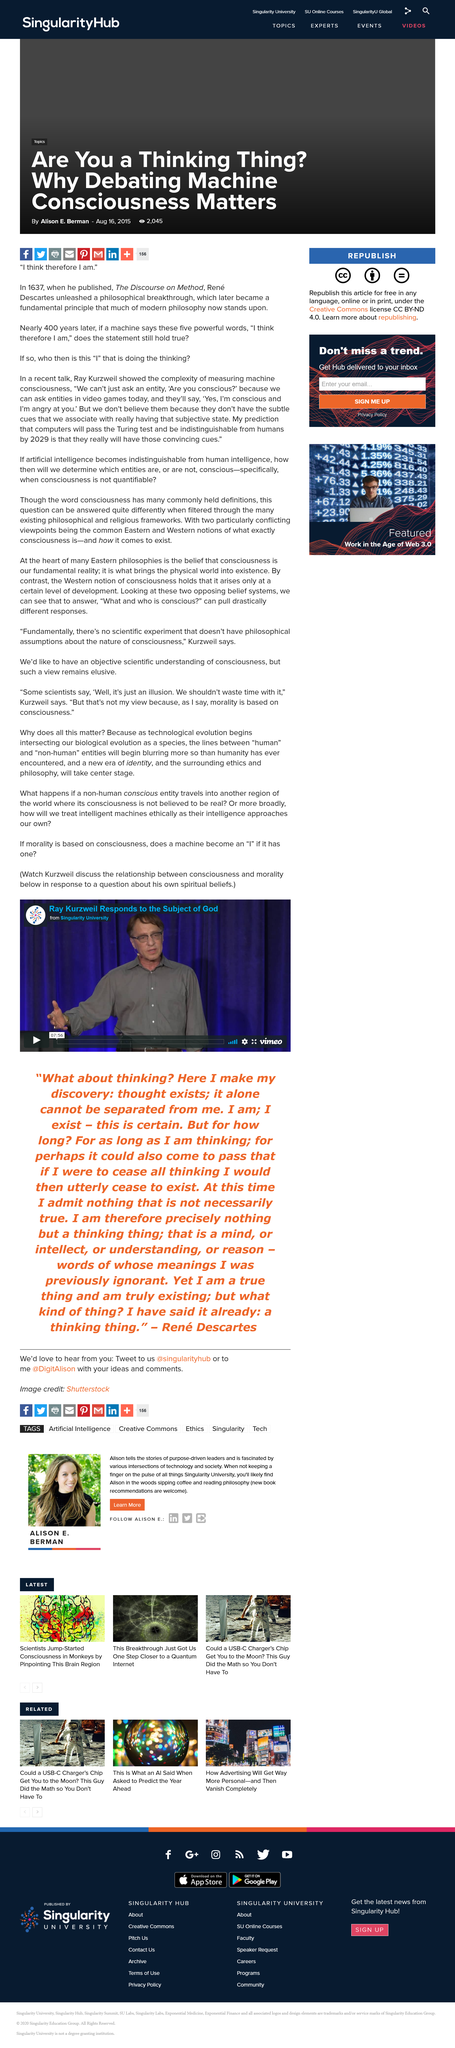Draw attention to some important aspects in this diagram. In the Singularity University Vimeo video, Ray Kurzweil talks about the subject of God and responds to it. The final quote is by René Descartes. The blurring of the lines between human and non-human entities due to technological evolution is a declaration of the evolution of technology and its impact on society. 